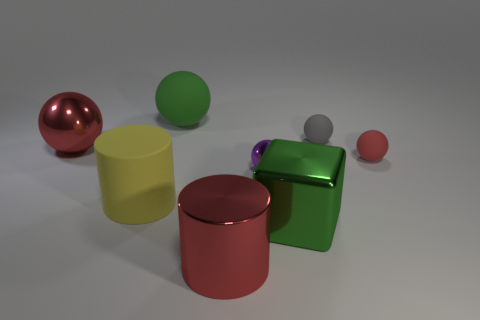Add 1 purple matte objects. How many objects exist? 9 Subtract all cubes. How many objects are left? 7 Add 3 tiny blue metal balls. How many tiny blue metal balls exist? 3 Subtract 0 gray cubes. How many objects are left? 8 Subtract all large purple shiny cylinders. Subtract all yellow matte cylinders. How many objects are left? 7 Add 6 small objects. How many small objects are left? 9 